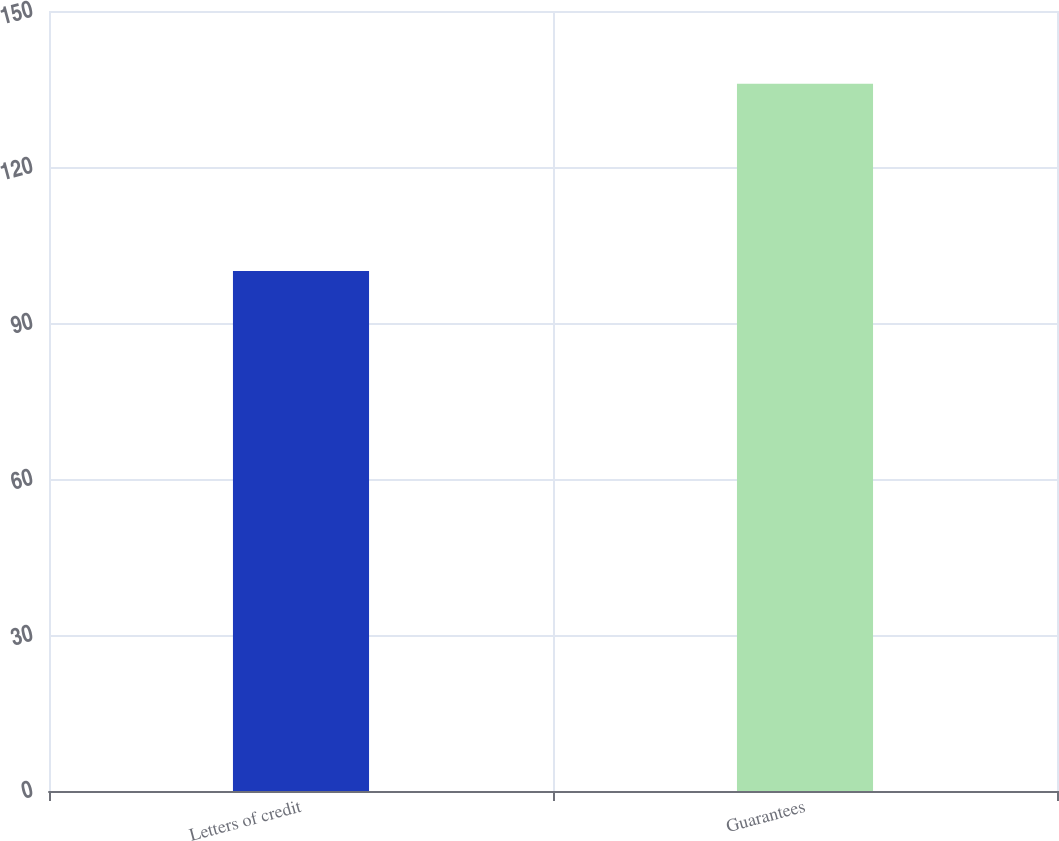Convert chart. <chart><loc_0><loc_0><loc_500><loc_500><bar_chart><fcel>Letters of credit<fcel>Guarantees<nl><fcel>100<fcel>136<nl></chart> 